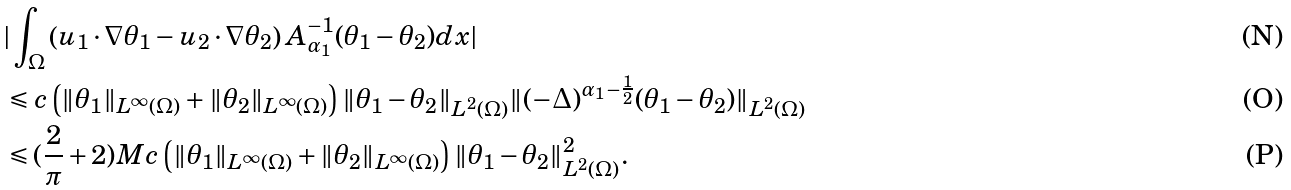Convert formula to latex. <formula><loc_0><loc_0><loc_500><loc_500>& | \int _ { \Omega } \left ( u _ { 1 } \cdot \nabla \theta _ { 1 } - u _ { 2 } \cdot \nabla \theta _ { 2 } \right ) A _ { \alpha _ { 1 } } ^ { - 1 } ( \theta _ { 1 } - \theta _ { 2 } ) d x | \\ & \leqslant c \left ( \| \theta _ { 1 } \| _ { L ^ { \infty } ( \Omega ) } + \| \theta _ { 2 } \| _ { L ^ { \infty } ( \Omega ) } \right ) \| \theta _ { 1 } - \theta _ { 2 } \| _ { L ^ { 2 } ( \Omega ) } \| ( - \Delta ) ^ { \alpha _ { 1 } - \frac { 1 } { 2 } } ( \theta _ { 1 } - \theta _ { 2 } ) \| _ { L ^ { 2 } ( \Omega ) } \\ & \leqslant ( \frac { 2 } { \pi } + 2 ) M c \left ( \| \theta _ { 1 } \| _ { L ^ { \infty } ( \Omega ) } + \| \theta _ { 2 } \| _ { L ^ { \infty } ( \Omega ) } \right ) \| \theta _ { 1 } - \theta _ { 2 } \| ^ { 2 } _ { L ^ { 2 } ( \Omega ) } .</formula> 